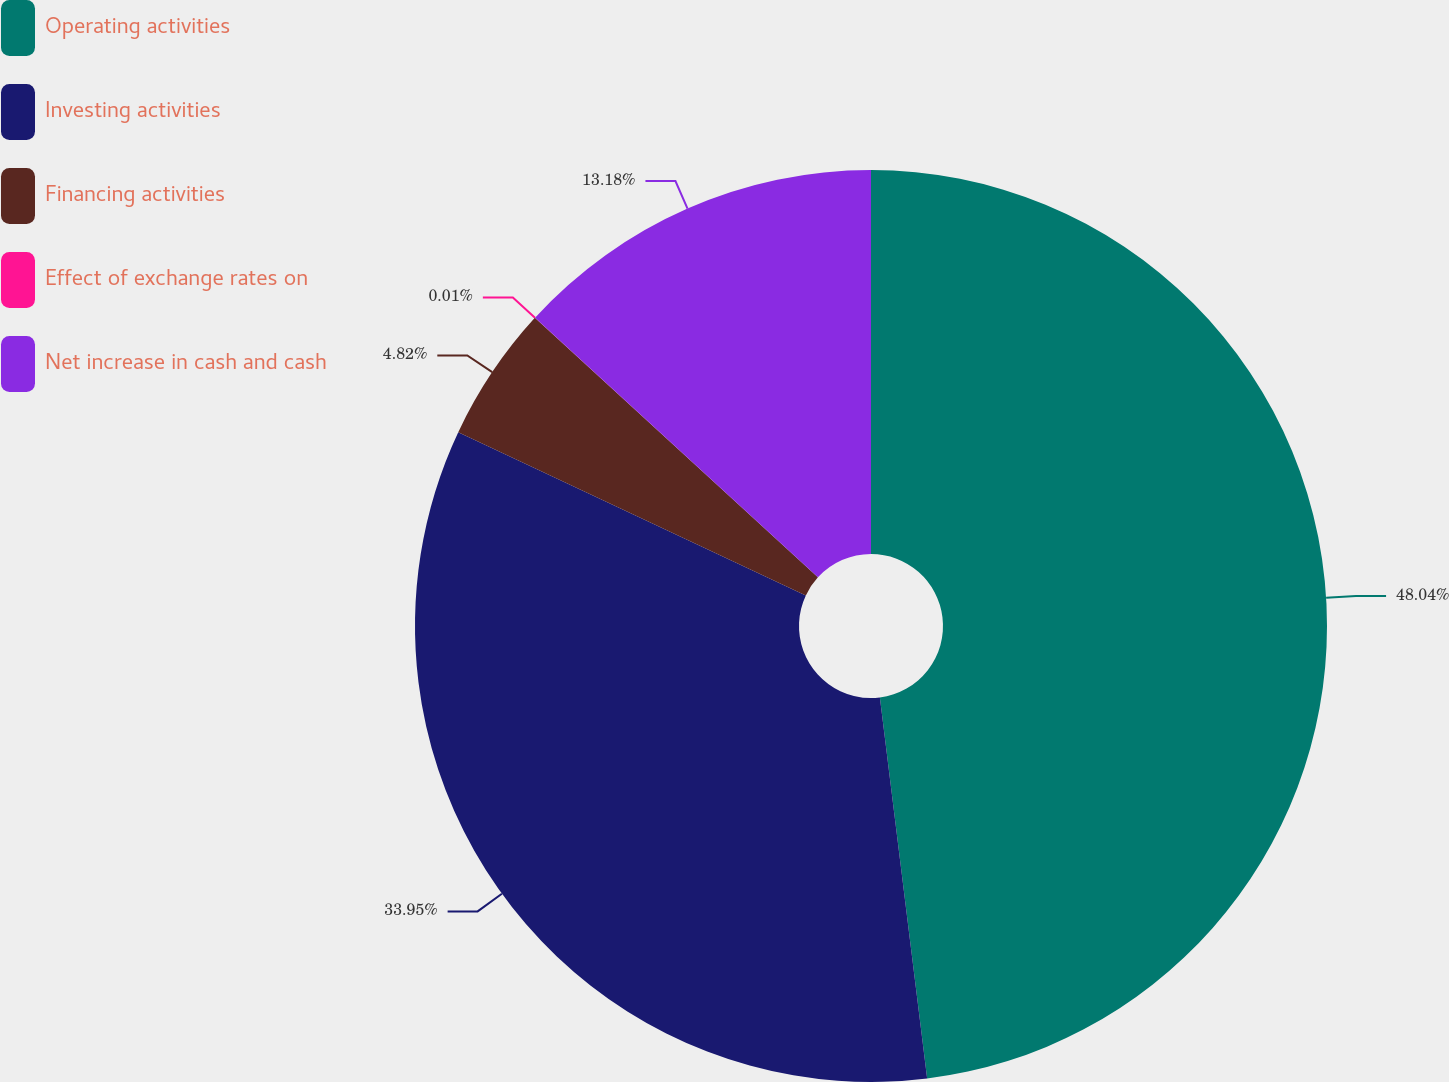<chart> <loc_0><loc_0><loc_500><loc_500><pie_chart><fcel>Operating activities<fcel>Investing activities<fcel>Financing activities<fcel>Effect of exchange rates on<fcel>Net increase in cash and cash<nl><fcel>48.03%<fcel>33.95%<fcel>4.82%<fcel>0.01%<fcel>13.18%<nl></chart> 